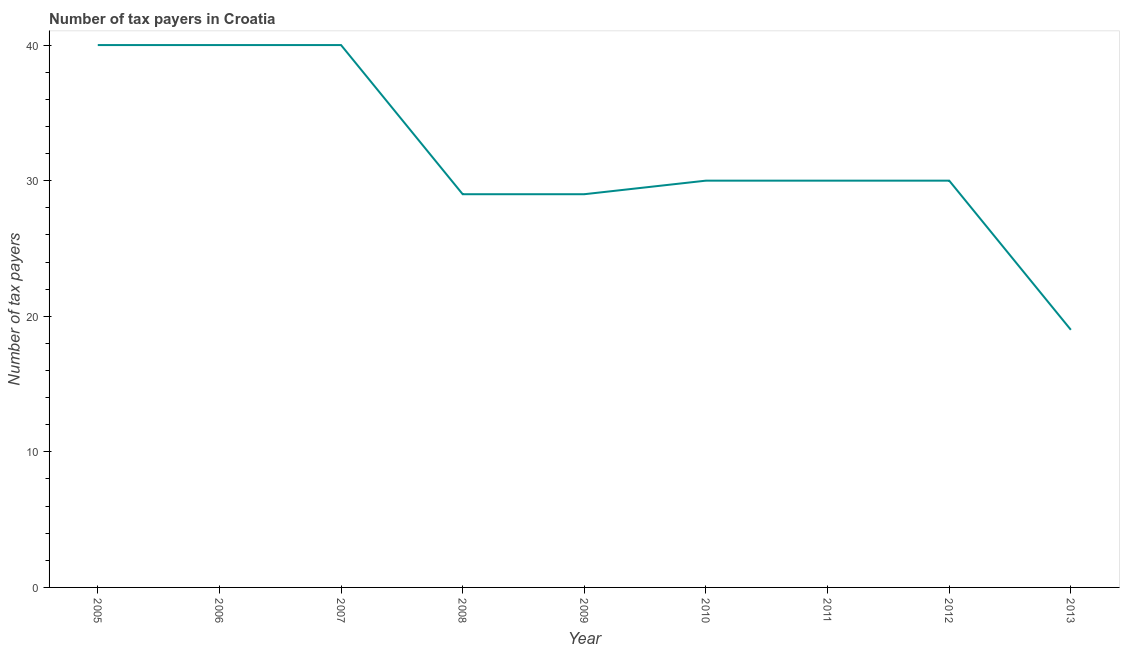What is the number of tax payers in 2005?
Give a very brief answer. 40. Across all years, what is the maximum number of tax payers?
Offer a very short reply. 40. Across all years, what is the minimum number of tax payers?
Ensure brevity in your answer.  19. What is the sum of the number of tax payers?
Offer a terse response. 287. What is the difference between the number of tax payers in 2008 and 2012?
Make the answer very short. -1. What is the average number of tax payers per year?
Give a very brief answer. 31.89. What is the median number of tax payers?
Make the answer very short. 30. Do a majority of the years between 2010 and 2005 (inclusive) have number of tax payers greater than 20 ?
Your response must be concise. Yes. What is the difference between the highest and the second highest number of tax payers?
Make the answer very short. 0. Is the sum of the number of tax payers in 2009 and 2012 greater than the maximum number of tax payers across all years?
Make the answer very short. Yes. What is the difference between the highest and the lowest number of tax payers?
Provide a succinct answer. 21. Does the number of tax payers monotonically increase over the years?
Make the answer very short. No. How many lines are there?
Keep it short and to the point. 1. What is the title of the graph?
Offer a very short reply. Number of tax payers in Croatia. What is the label or title of the Y-axis?
Ensure brevity in your answer.  Number of tax payers. What is the Number of tax payers in 2005?
Give a very brief answer. 40. What is the Number of tax payers in 2006?
Your response must be concise. 40. What is the Number of tax payers of 2008?
Ensure brevity in your answer.  29. What is the Number of tax payers of 2009?
Ensure brevity in your answer.  29. What is the Number of tax payers of 2010?
Offer a very short reply. 30. What is the Number of tax payers of 2011?
Offer a very short reply. 30. What is the Number of tax payers in 2012?
Your answer should be compact. 30. What is the difference between the Number of tax payers in 2005 and 2006?
Your response must be concise. 0. What is the difference between the Number of tax payers in 2005 and 2007?
Your answer should be compact. 0. What is the difference between the Number of tax payers in 2005 and 2008?
Provide a short and direct response. 11. What is the difference between the Number of tax payers in 2006 and 2007?
Ensure brevity in your answer.  0. What is the difference between the Number of tax payers in 2006 and 2009?
Provide a short and direct response. 11. What is the difference between the Number of tax payers in 2006 and 2010?
Your answer should be compact. 10. What is the difference between the Number of tax payers in 2006 and 2011?
Make the answer very short. 10. What is the difference between the Number of tax payers in 2006 and 2013?
Your answer should be compact. 21. What is the difference between the Number of tax payers in 2007 and 2008?
Your answer should be very brief. 11. What is the difference between the Number of tax payers in 2007 and 2009?
Your answer should be very brief. 11. What is the difference between the Number of tax payers in 2007 and 2010?
Your answer should be compact. 10. What is the difference between the Number of tax payers in 2007 and 2011?
Provide a succinct answer. 10. What is the difference between the Number of tax payers in 2007 and 2012?
Your answer should be compact. 10. What is the difference between the Number of tax payers in 2007 and 2013?
Your response must be concise. 21. What is the difference between the Number of tax payers in 2008 and 2009?
Give a very brief answer. 0. What is the difference between the Number of tax payers in 2008 and 2010?
Your answer should be very brief. -1. What is the difference between the Number of tax payers in 2008 and 2011?
Make the answer very short. -1. What is the difference between the Number of tax payers in 2009 and 2010?
Provide a succinct answer. -1. What is the difference between the Number of tax payers in 2009 and 2013?
Give a very brief answer. 10. What is the difference between the Number of tax payers in 2010 and 2012?
Offer a terse response. 0. What is the difference between the Number of tax payers in 2010 and 2013?
Your response must be concise. 11. What is the difference between the Number of tax payers in 2011 and 2013?
Provide a succinct answer. 11. What is the difference between the Number of tax payers in 2012 and 2013?
Offer a very short reply. 11. What is the ratio of the Number of tax payers in 2005 to that in 2006?
Offer a terse response. 1. What is the ratio of the Number of tax payers in 2005 to that in 2008?
Give a very brief answer. 1.38. What is the ratio of the Number of tax payers in 2005 to that in 2009?
Keep it short and to the point. 1.38. What is the ratio of the Number of tax payers in 2005 to that in 2010?
Provide a succinct answer. 1.33. What is the ratio of the Number of tax payers in 2005 to that in 2011?
Provide a short and direct response. 1.33. What is the ratio of the Number of tax payers in 2005 to that in 2012?
Keep it short and to the point. 1.33. What is the ratio of the Number of tax payers in 2005 to that in 2013?
Ensure brevity in your answer.  2.1. What is the ratio of the Number of tax payers in 2006 to that in 2008?
Make the answer very short. 1.38. What is the ratio of the Number of tax payers in 2006 to that in 2009?
Your response must be concise. 1.38. What is the ratio of the Number of tax payers in 2006 to that in 2010?
Keep it short and to the point. 1.33. What is the ratio of the Number of tax payers in 2006 to that in 2011?
Ensure brevity in your answer.  1.33. What is the ratio of the Number of tax payers in 2006 to that in 2012?
Your answer should be compact. 1.33. What is the ratio of the Number of tax payers in 2006 to that in 2013?
Keep it short and to the point. 2.1. What is the ratio of the Number of tax payers in 2007 to that in 2008?
Give a very brief answer. 1.38. What is the ratio of the Number of tax payers in 2007 to that in 2009?
Keep it short and to the point. 1.38. What is the ratio of the Number of tax payers in 2007 to that in 2010?
Your answer should be compact. 1.33. What is the ratio of the Number of tax payers in 2007 to that in 2011?
Provide a succinct answer. 1.33. What is the ratio of the Number of tax payers in 2007 to that in 2012?
Give a very brief answer. 1.33. What is the ratio of the Number of tax payers in 2007 to that in 2013?
Provide a succinct answer. 2.1. What is the ratio of the Number of tax payers in 2008 to that in 2009?
Provide a short and direct response. 1. What is the ratio of the Number of tax payers in 2008 to that in 2010?
Ensure brevity in your answer.  0.97. What is the ratio of the Number of tax payers in 2008 to that in 2013?
Make the answer very short. 1.53. What is the ratio of the Number of tax payers in 2009 to that in 2010?
Ensure brevity in your answer.  0.97. What is the ratio of the Number of tax payers in 2009 to that in 2013?
Give a very brief answer. 1.53. What is the ratio of the Number of tax payers in 2010 to that in 2011?
Ensure brevity in your answer.  1. What is the ratio of the Number of tax payers in 2010 to that in 2012?
Your response must be concise. 1. What is the ratio of the Number of tax payers in 2010 to that in 2013?
Your response must be concise. 1.58. What is the ratio of the Number of tax payers in 2011 to that in 2012?
Keep it short and to the point. 1. What is the ratio of the Number of tax payers in 2011 to that in 2013?
Ensure brevity in your answer.  1.58. What is the ratio of the Number of tax payers in 2012 to that in 2013?
Your response must be concise. 1.58. 